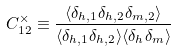Convert formula to latex. <formula><loc_0><loc_0><loc_500><loc_500>C _ { 1 2 } ^ { \times } \equiv \frac { \langle \delta _ { h , 1 } \delta _ { h , 2 } \delta _ { m , 2 } \rangle } { \langle \delta _ { h , 1 } \delta _ { h , 2 } \rangle \langle \delta _ { h } \delta _ { m } \rangle }</formula> 